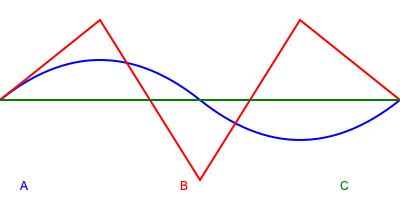In the context of M83's dreamy synth-scapes, which waveform represented in the graph above would most likely be used to create a soft, atmospheric pad sound? To answer this question, let's analyze each waveform:

1. Waveform A (blue): This is a sine wave, characterized by its smooth, rounded shape. Sine waves are known for their pure, soft tone without harmonics.

2. Waveform B (red): This is a triangle wave, recognizable by its linear rise and fall. Triangle waves have a slightly brighter sound than sine waves but are still relatively soft.

3. Waveform C (green): This is a square wave, identifiable by its constant amplitude and abrupt changes. Square waves have a harsh, buzzy quality due to their rich harmonic content.

In the context of M83's dreamy synth-scapes:

- Soft, atmospheric pad sounds typically require waveforms with fewer harmonics to create a smooth, ethereal texture.
- Sine waves (A) are ideal for this purpose, as they produce the purest and softest tones.
- Triangle waves (B) could also be used but would create a slightly brighter pad sound.
- Square waves (C) are too harsh and rich in harmonics for a soft, atmospheric pad, though they might be used for other elements in M83's music.

Therefore, the waveform most likely to be used for a soft, atmospheric pad sound in M83's dreamy synth-scapes would be the sine wave (A).
Answer: Sine wave (A) 